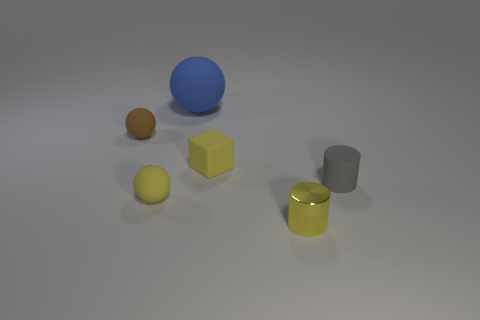Add 2 tiny brown balls. How many objects exist? 8 Subtract all cylinders. How many objects are left? 4 Add 2 small gray rubber objects. How many small gray rubber objects are left? 3 Add 2 small green objects. How many small green objects exist? 2 Subtract 1 brown balls. How many objects are left? 5 Subtract all large blue objects. Subtract all small cubes. How many objects are left? 4 